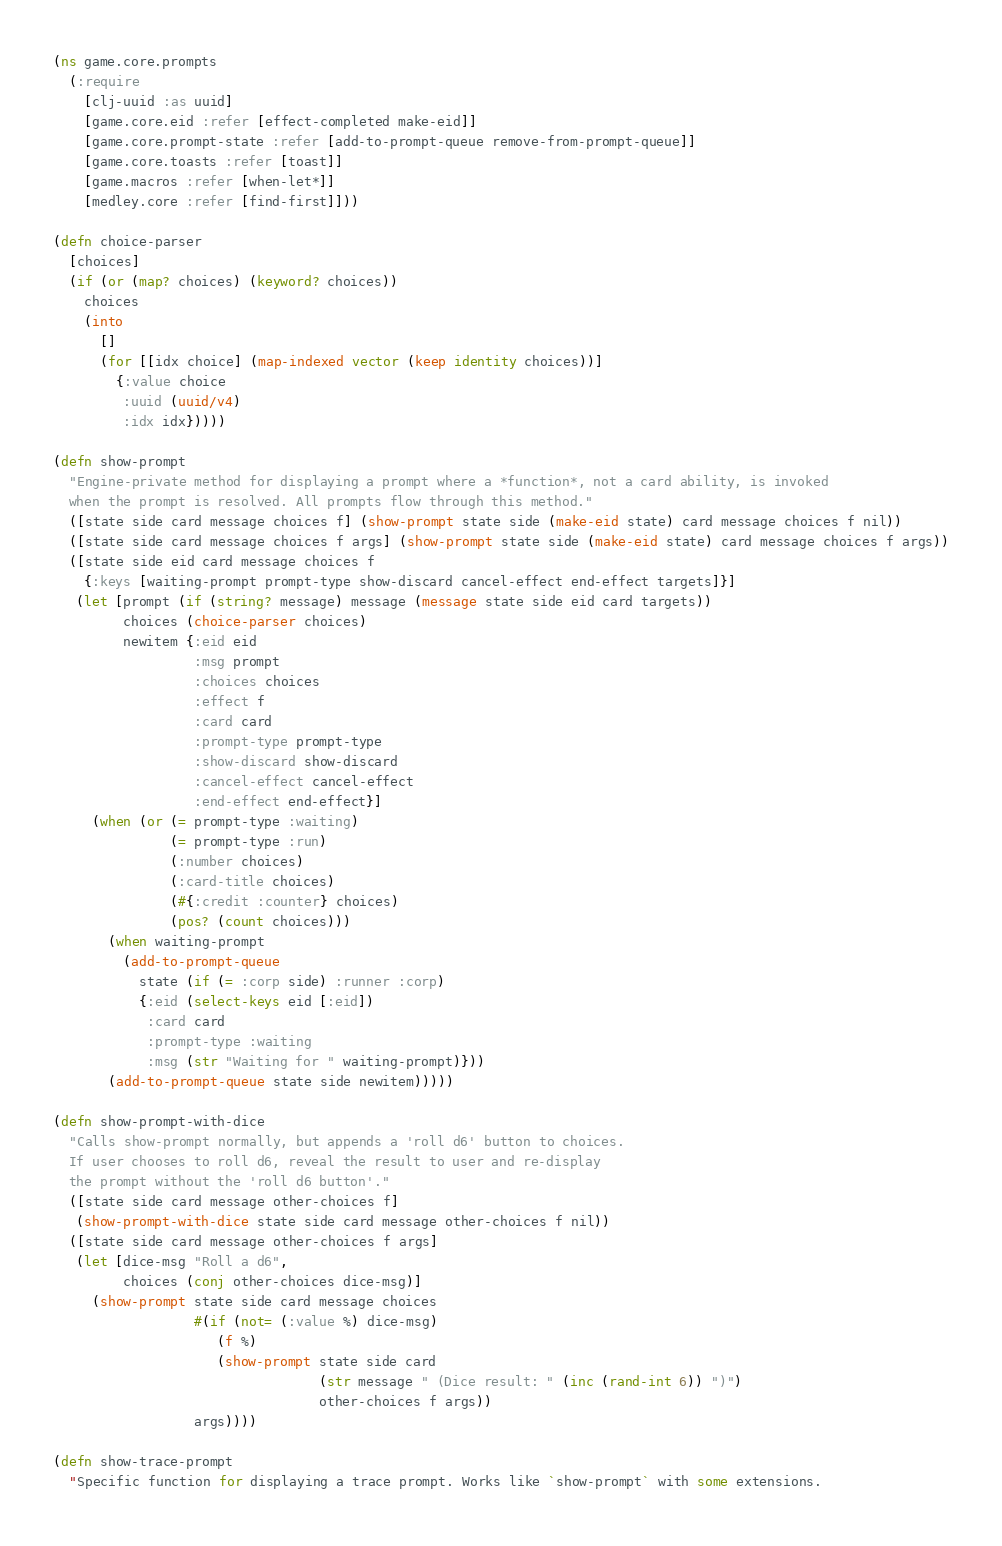Convert code to text. <code><loc_0><loc_0><loc_500><loc_500><_Clojure_>(ns game.core.prompts
  (:require
    [clj-uuid :as uuid]
    [game.core.eid :refer [effect-completed make-eid]]
    [game.core.prompt-state :refer [add-to-prompt-queue remove-from-prompt-queue]]
    [game.core.toasts :refer [toast]]
    [game.macros :refer [when-let*]]
    [medley.core :refer [find-first]]))

(defn choice-parser
  [choices]
  (if (or (map? choices) (keyword? choices))
    choices
    (into
      []
      (for [[idx choice] (map-indexed vector (keep identity choices))]
        {:value choice
         :uuid (uuid/v4)
         :idx idx}))))

(defn show-prompt
  "Engine-private method for displaying a prompt where a *function*, not a card ability, is invoked
  when the prompt is resolved. All prompts flow through this method."
  ([state side card message choices f] (show-prompt state side (make-eid state) card message choices f nil))
  ([state side card message choices f args] (show-prompt state side (make-eid state) card message choices f args))
  ([state side eid card message choices f
    {:keys [waiting-prompt prompt-type show-discard cancel-effect end-effect targets]}]
   (let [prompt (if (string? message) message (message state side eid card targets))
         choices (choice-parser choices)
         newitem {:eid eid
                  :msg prompt
                  :choices choices
                  :effect f
                  :card card
                  :prompt-type prompt-type
                  :show-discard show-discard
                  :cancel-effect cancel-effect
                  :end-effect end-effect}]
     (when (or (= prompt-type :waiting)
               (= prompt-type :run)
               (:number choices)
               (:card-title choices)
               (#{:credit :counter} choices)
               (pos? (count choices)))
       (when waiting-prompt
         (add-to-prompt-queue
           state (if (= :corp side) :runner :corp)
           {:eid (select-keys eid [:eid])
            :card card
            :prompt-type :waiting
            :msg (str "Waiting for " waiting-prompt)}))
       (add-to-prompt-queue state side newitem)))))

(defn show-prompt-with-dice
  "Calls show-prompt normally, but appends a 'roll d6' button to choices.
  If user chooses to roll d6, reveal the result to user and re-display
  the prompt without the 'roll d6 button'."
  ([state side card message other-choices f]
   (show-prompt-with-dice state side card message other-choices f nil))
  ([state side card message other-choices f args]
   (let [dice-msg "Roll a d6",
         choices (conj other-choices dice-msg)]
     (show-prompt state side card message choices
                  #(if (not= (:value %) dice-msg)
                     (f %)
                     (show-prompt state side card
                                  (str message " (Dice result: " (inc (rand-int 6)) ")")
                                  other-choices f args))
                  args))))

(defn show-trace-prompt
  "Specific function for displaying a trace prompt. Works like `show-prompt` with some extensions.</code> 